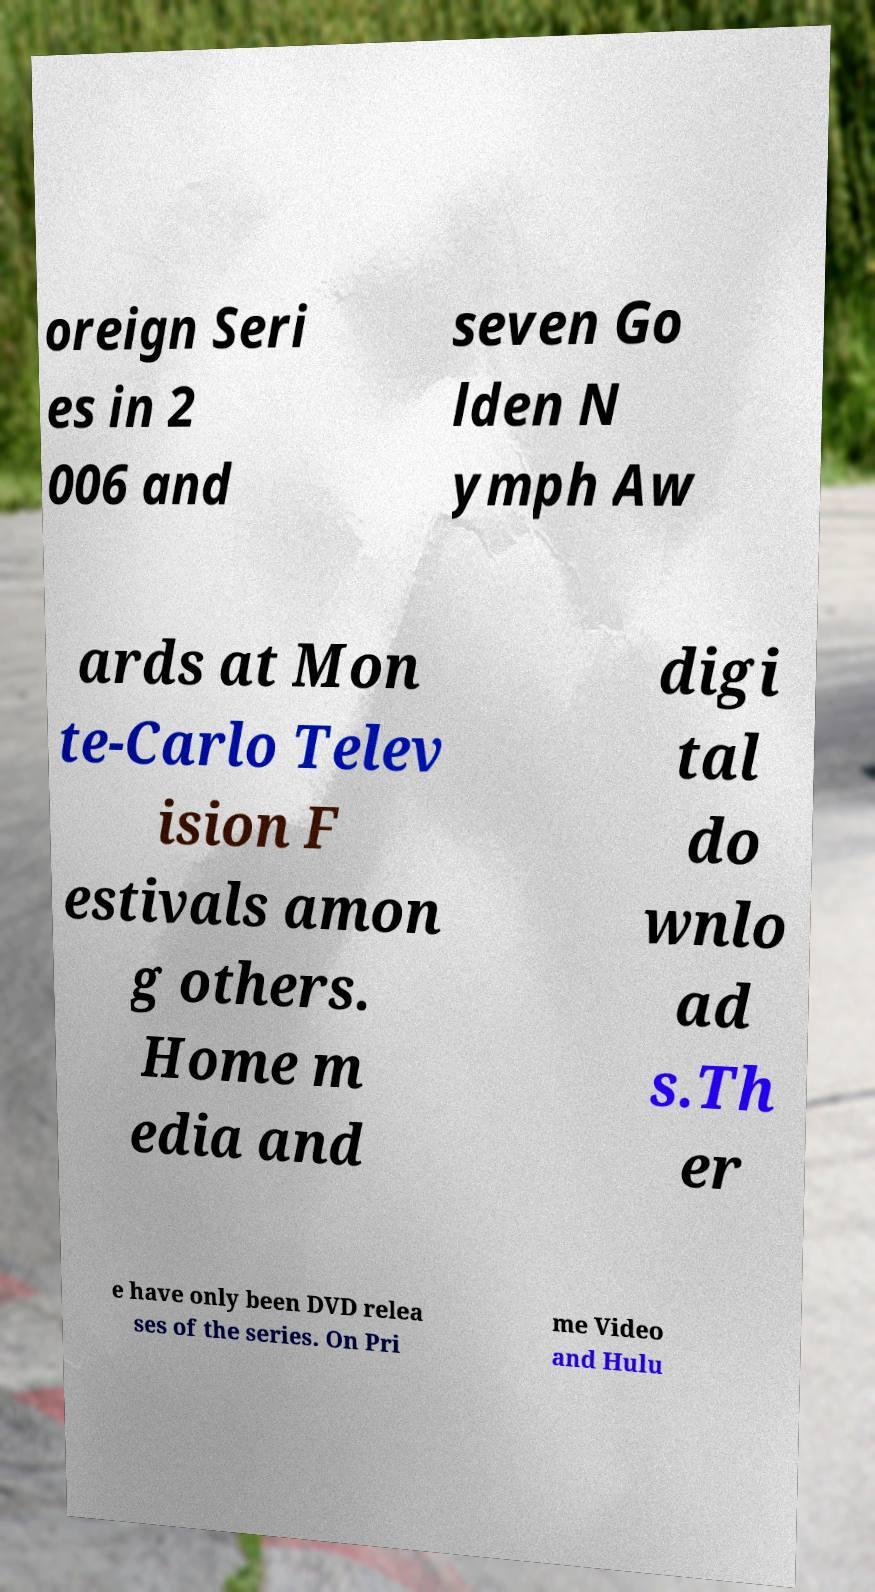Could you extract and type out the text from this image? oreign Seri es in 2 006 and seven Go lden N ymph Aw ards at Mon te-Carlo Telev ision F estivals amon g others. Home m edia and digi tal do wnlo ad s.Th er e have only been DVD relea ses of the series. On Pri me Video and Hulu 